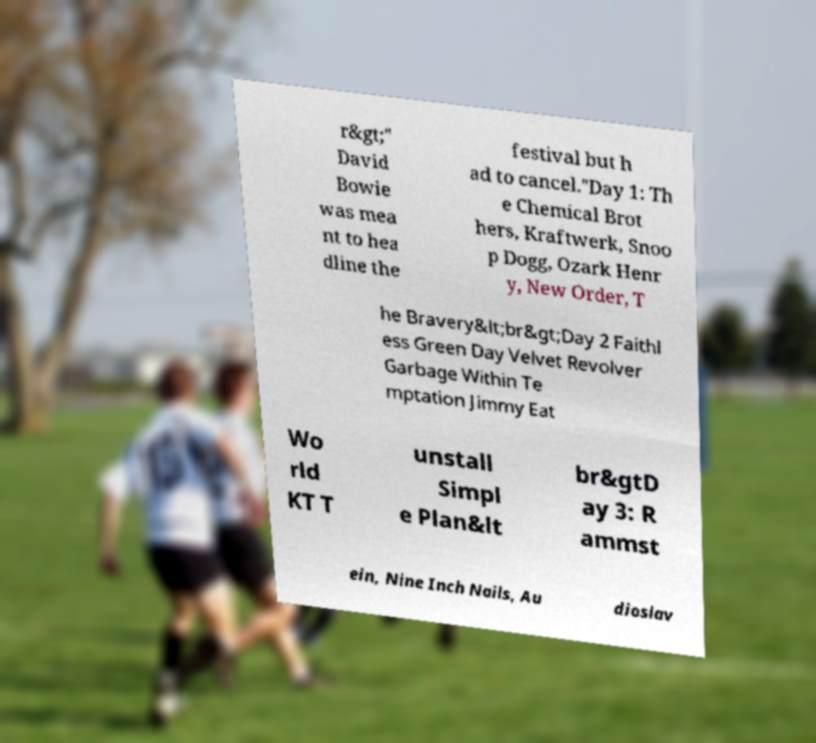What messages or text are displayed in this image? I need them in a readable, typed format. r&gt;" David Bowie was mea nt to hea dline the festival but h ad to cancel."Day 1: Th e Chemical Brot hers, Kraftwerk, Snoo p Dogg, Ozark Henr y, New Order, T he Bravery&lt;br&gt;Day 2 Faithl ess Green Day Velvet Revolver Garbage Within Te mptation Jimmy Eat Wo rld KT T unstall Simpl e Plan&lt br&gtD ay 3: R ammst ein, Nine Inch Nails, Au dioslav 